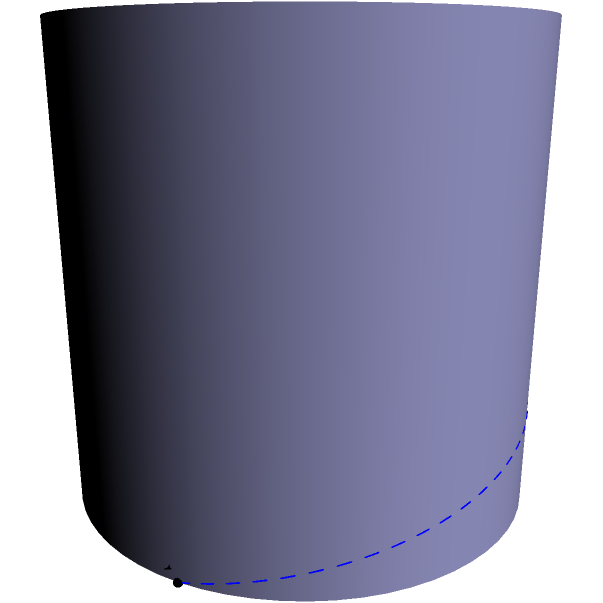Consider a cylindrical ocean surface represented by the equation $x^2 + y^2 = 4$. Point A is located at $(2,0,0)$ and point B is at $(-2,0,1.5)$. Which path represents the shortest distance between these two points: the straight line (red) or the curved path (blue dashed line) following the surface? Explain your reasoning. To determine the shortest path between two points on a curved surface, we need to consider the principles of geodesics in non-Euclidean geometry. Let's approach this step-by-step:

1) In Euclidean geometry, the shortest path between two points is always a straight line. However, on curved surfaces, this is not always the case.

2) On a cylindrical surface, the shortest path between two points is not necessarily a straight line through space, but rather a geodesic on the surface.

3) For a cylinder, geodesics can be of two types:
   a) A straight line parallel to the cylinder's axis
   b) A helix wrapping around the cylinder

4) In this case, points A and B are not directly above/below each other, so the geodesic will be a helix.

5) The blue dashed line in the diagram represents this helical path on the surface of the cylinder.

6) Although the red straight line appears shorter in three-dimensional space, it does not lie on the surface of the cylinder.

7) To travel along the red line, one would have to leave the ocean's surface, which is not possible for a surfer.

8) The blue helical path, while longer in Euclidean space, represents the shortest possible path a surfer could take while staying on the ocean's surface.

Therefore, the blue dashed line (helical path) represents the shortest distance between points A and B on the cylindrical ocean surface.
Answer: The curved path (blue dashed line) following the surface 